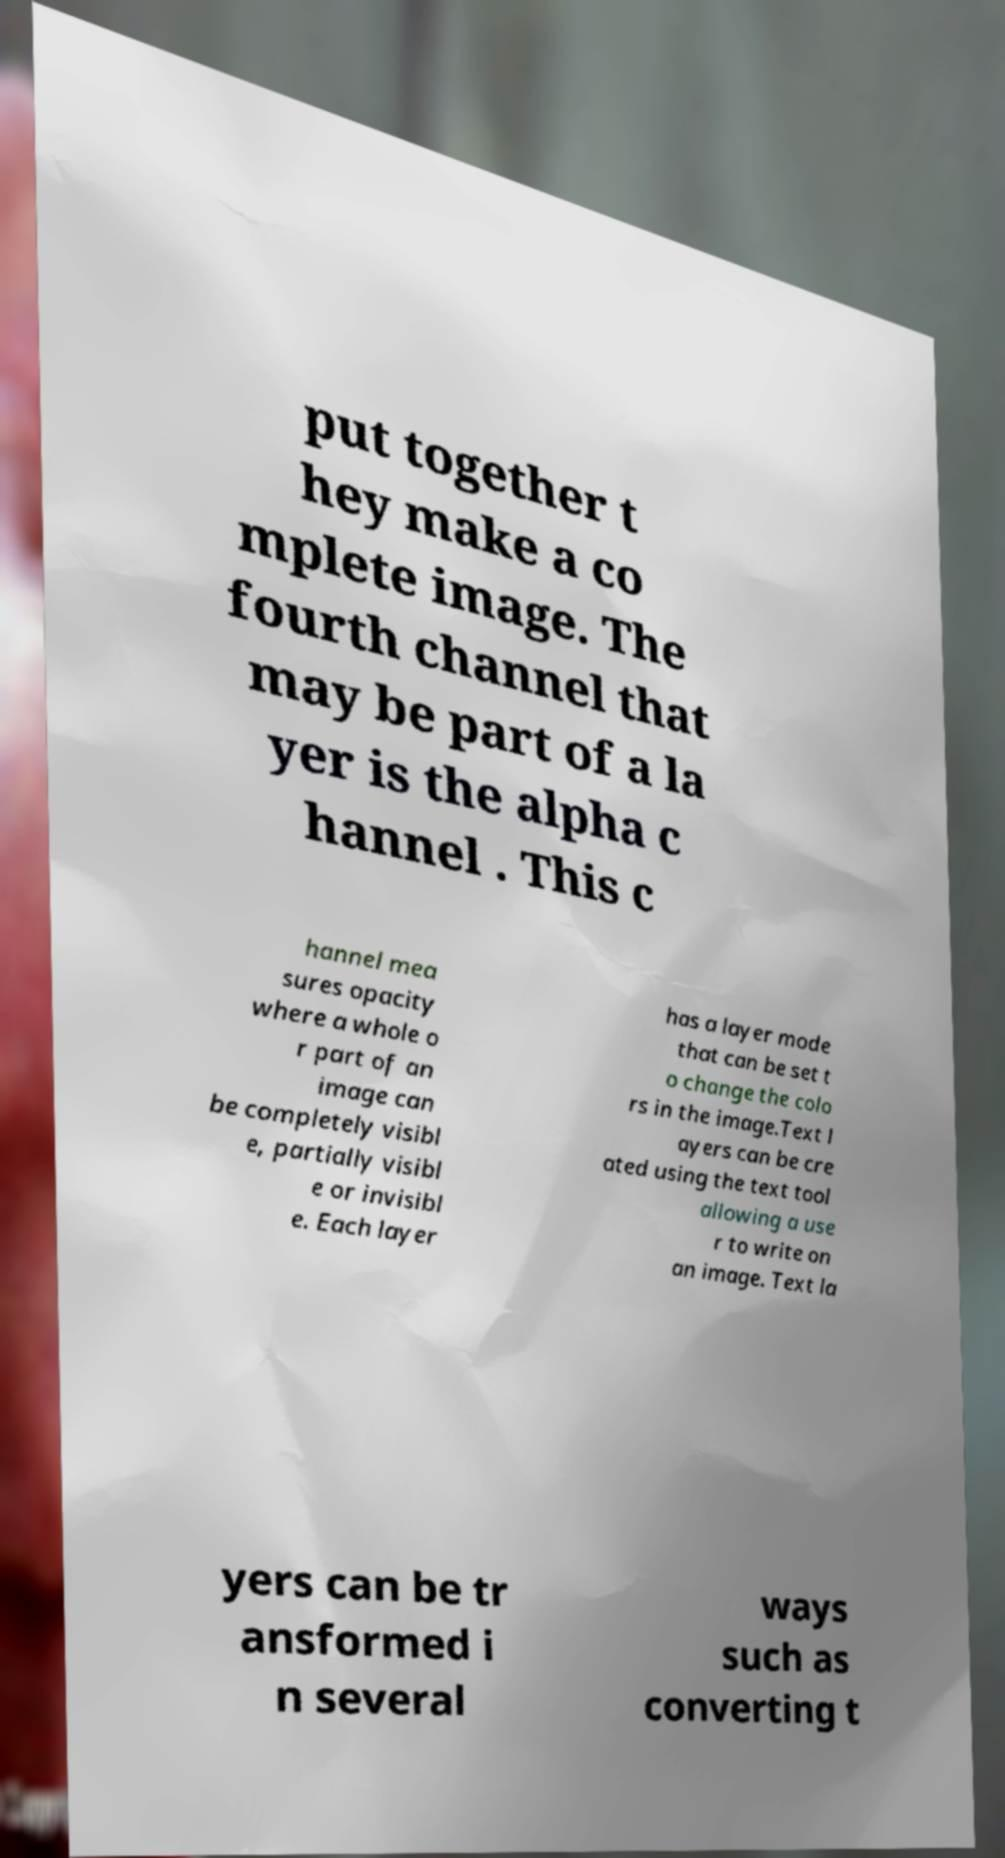Could you extract and type out the text from this image? put together t hey make a co mplete image. The fourth channel that may be part of a la yer is the alpha c hannel . This c hannel mea sures opacity where a whole o r part of an image can be completely visibl e, partially visibl e or invisibl e. Each layer has a layer mode that can be set t o change the colo rs in the image.Text l ayers can be cre ated using the text tool allowing a use r to write on an image. Text la yers can be tr ansformed i n several ways such as converting t 